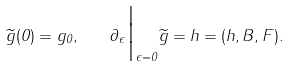Convert formula to latex. <formula><loc_0><loc_0><loc_500><loc_500>\widetilde { g } ( 0 ) = g _ { 0 } , \quad \partial _ { \epsilon } \Big | _ { \epsilon = 0 } \widetilde { g } = h = ( h , B , F ) .</formula> 